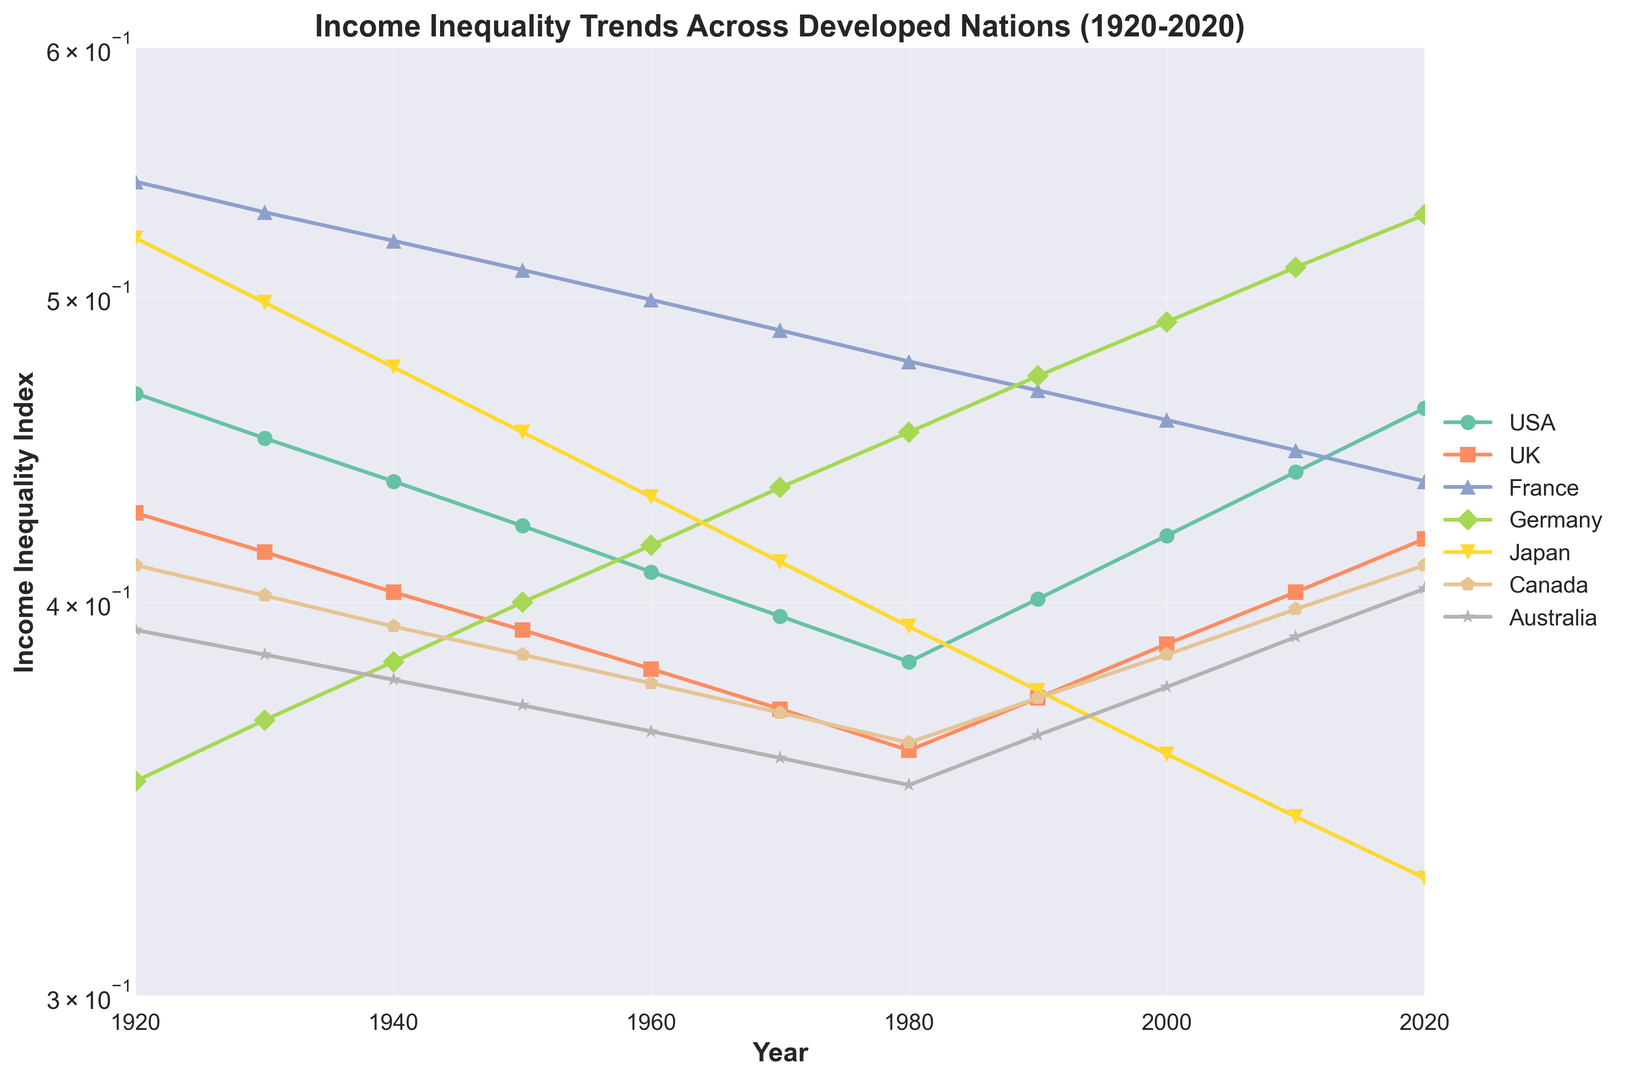what's the general trend in income inequality in the USA from 1920 to 2020? Income inequality in the USA shows a U-shaped trend. Initially, it decreases from 1920 to 1980, and then it starts to increase again from 1980 to 2020, indicating that inequality was at its lowest around 1980.
Answer: U-shaped which country experienced the greatest decrease in income inequality over the century? By looking at the chart, France experienced the greatest decrease in income inequality, starting from around 0.544 in 1920 to around 0.437 in 2020, which is approximately a 0.107 decrease.
Answer: France how does the income inequality in Germany in 2020 compare to Japan in 2020? Germany's income inequality index in 2020 is around 0.531, whereas Japan's is around 0.327. This comparison shows that Germany has a higher income inequality than Japan.
Answer: Germany > Japan which country has the most stable income inequality trend throughout the century? Canada shows the most stable trend in income inequality, with values fluctuating very little around 0.385 over the century.
Answer: Canada when did Australia overtakes Canada in terms of income inequality? Australia overtakes Canada in terms of income inequality after 1970. In 1970, Canada's index was 0.369 while Australia's was 0.357, and from 1980 onwards, Australia consistently showed higher income inequality than Canada.
Answer: After 1970 what is the average income inequality in the UK from 1920 to 2020? To find the average income inequality in the UK from 1920 to 2020, sum up the given values and divide by the number of data points. (0.427 + 0.415 + 0.403 + 0.392 + 0.381 + 0.370 + 0.359 + 0.373 + 0.388 + 0.403 + 0.419)/11 = 4.430/11 = 0.403.
Answer: 0.403 which country's income inequality trend in 1940 is closest to the USA's trend in 2000? Australia's income inequality index in 1940 is around 0.378, which is the closest to the USA's index in 2000 of around 0.420.
Answer: Australia how much did income inequality in France change from 1940 to 1980? Income inequality in France decreased from around 0.521 in 1940 to around 0.477 in 1980. The change is 0.521 - 0.477 = 0.044.
Answer: 0.044 which decade shows the sharpest increase in income inequality for Germany? The sharpest increase in income inequality for Germany occurred between 1980 and 1990, where the index rose from 0.453 to 0.472.
Answer: 1980-1990 what is the range of income inequality in Japan over the entire century? The range is calculated by subtracting the minimum value from the maximum value. For Japan, the highest value is around 0.522 (1920) and the lowest is around 0.327 (2020), so the range is 0.522 - 0.327 = 0.195.
Answer: 0.195 